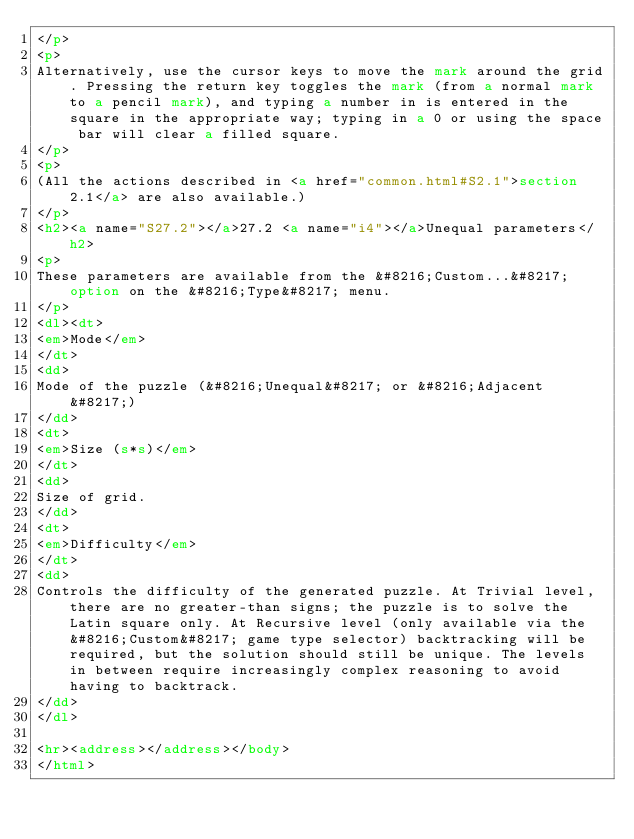<code> <loc_0><loc_0><loc_500><loc_500><_HTML_></p>
<p>
Alternatively, use the cursor keys to move the mark around the grid. Pressing the return key toggles the mark (from a normal mark to a pencil mark), and typing a number in is entered in the square in the appropriate way; typing in a 0 or using the space bar will clear a filled square.
</p>
<p>
(All the actions described in <a href="common.html#S2.1">section 2.1</a> are also available.)
</p>
<h2><a name="S27.2"></a>27.2 <a name="i4"></a>Unequal parameters</h2>
<p>
These parameters are available from the &#8216;Custom...&#8217; option on the &#8216;Type&#8217; menu.
</p>
<dl><dt>
<em>Mode</em>
</dt>
<dd>
Mode of the puzzle (&#8216;Unequal&#8217; or &#8216;Adjacent&#8217;)
</dd>
<dt>
<em>Size (s*s)</em>
</dt>
<dd>
Size of grid.
</dd>
<dt>
<em>Difficulty</em>
</dt>
<dd>
Controls the difficulty of the generated puzzle. At Trivial level, there are no greater-than signs; the puzzle is to solve the Latin square only. At Recursive level (only available via the &#8216;Custom&#8217; game type selector) backtracking will be required, but the solution should still be unique. The levels in between require increasingly complex reasoning to avoid having to backtrack.
</dd>
</dl>

<hr><address></address></body>
</html>
</code> 